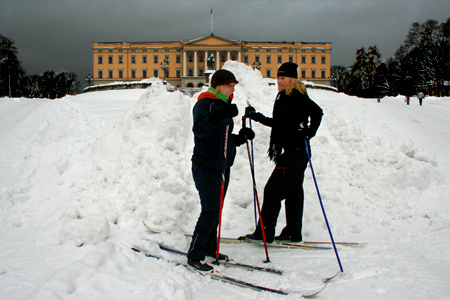Suppose this image was taken during the last few minutes before a significant historical event. What event could that be? This image might have been captured just moments before the official inauguration of the monumental building behind them. The two individuals present could be government officials or security personnel ensuring everything is in place before the grand ceremony begins. The overcast sky adds to the tension and anticipation as they make final preparations, soon to witness a defining moment in their country's history.  What if this image was the last photo taken before a snowstorm hit? Describe what happens next. If this image was taken just before a snowstorm hit, the next few moments would see the sky darken even further as heavy snowfall begins. The two individuals might hasten their conversation, deciding whether to seek shelter immediately or brave the storm and continue skiing for a while longer. The scene would quickly transform as the snowfall intensifies, visibility diminishes, and the landscape becomes blanketed with fresh layers of snow. They would either find their way to safety or experience the raw, powerful beauty of nature's winter fury. 